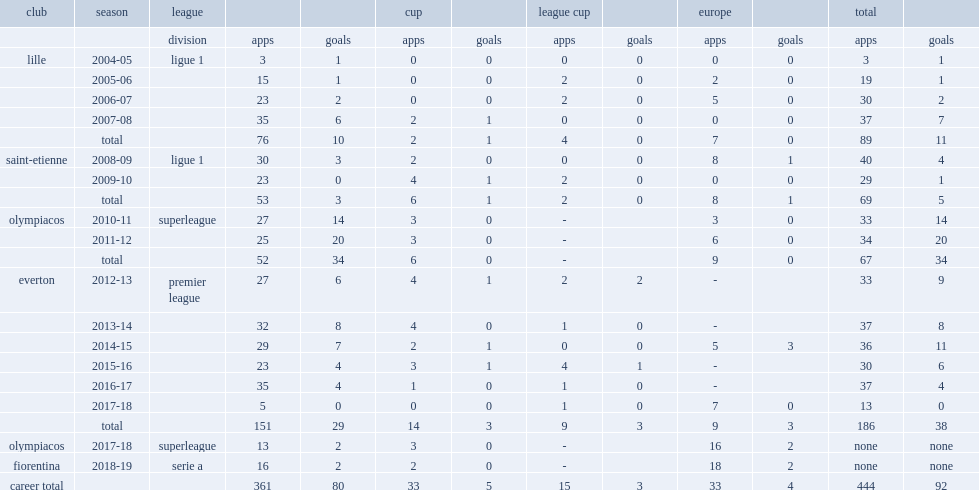Which club did mirallas play for in the 2013-14 season? Everton. 